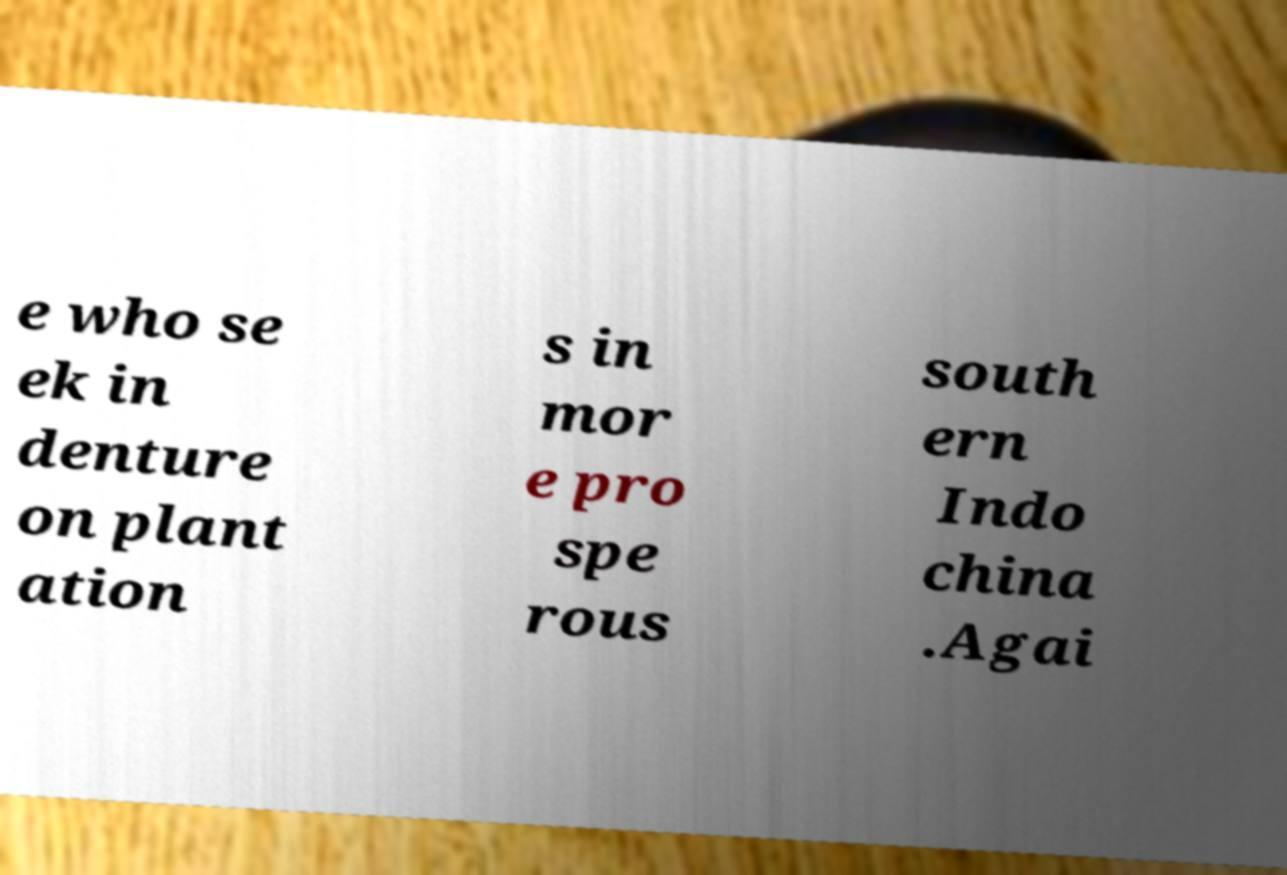What messages or text are displayed in this image? I need them in a readable, typed format. e who se ek in denture on plant ation s in mor e pro spe rous south ern Indo china .Agai 